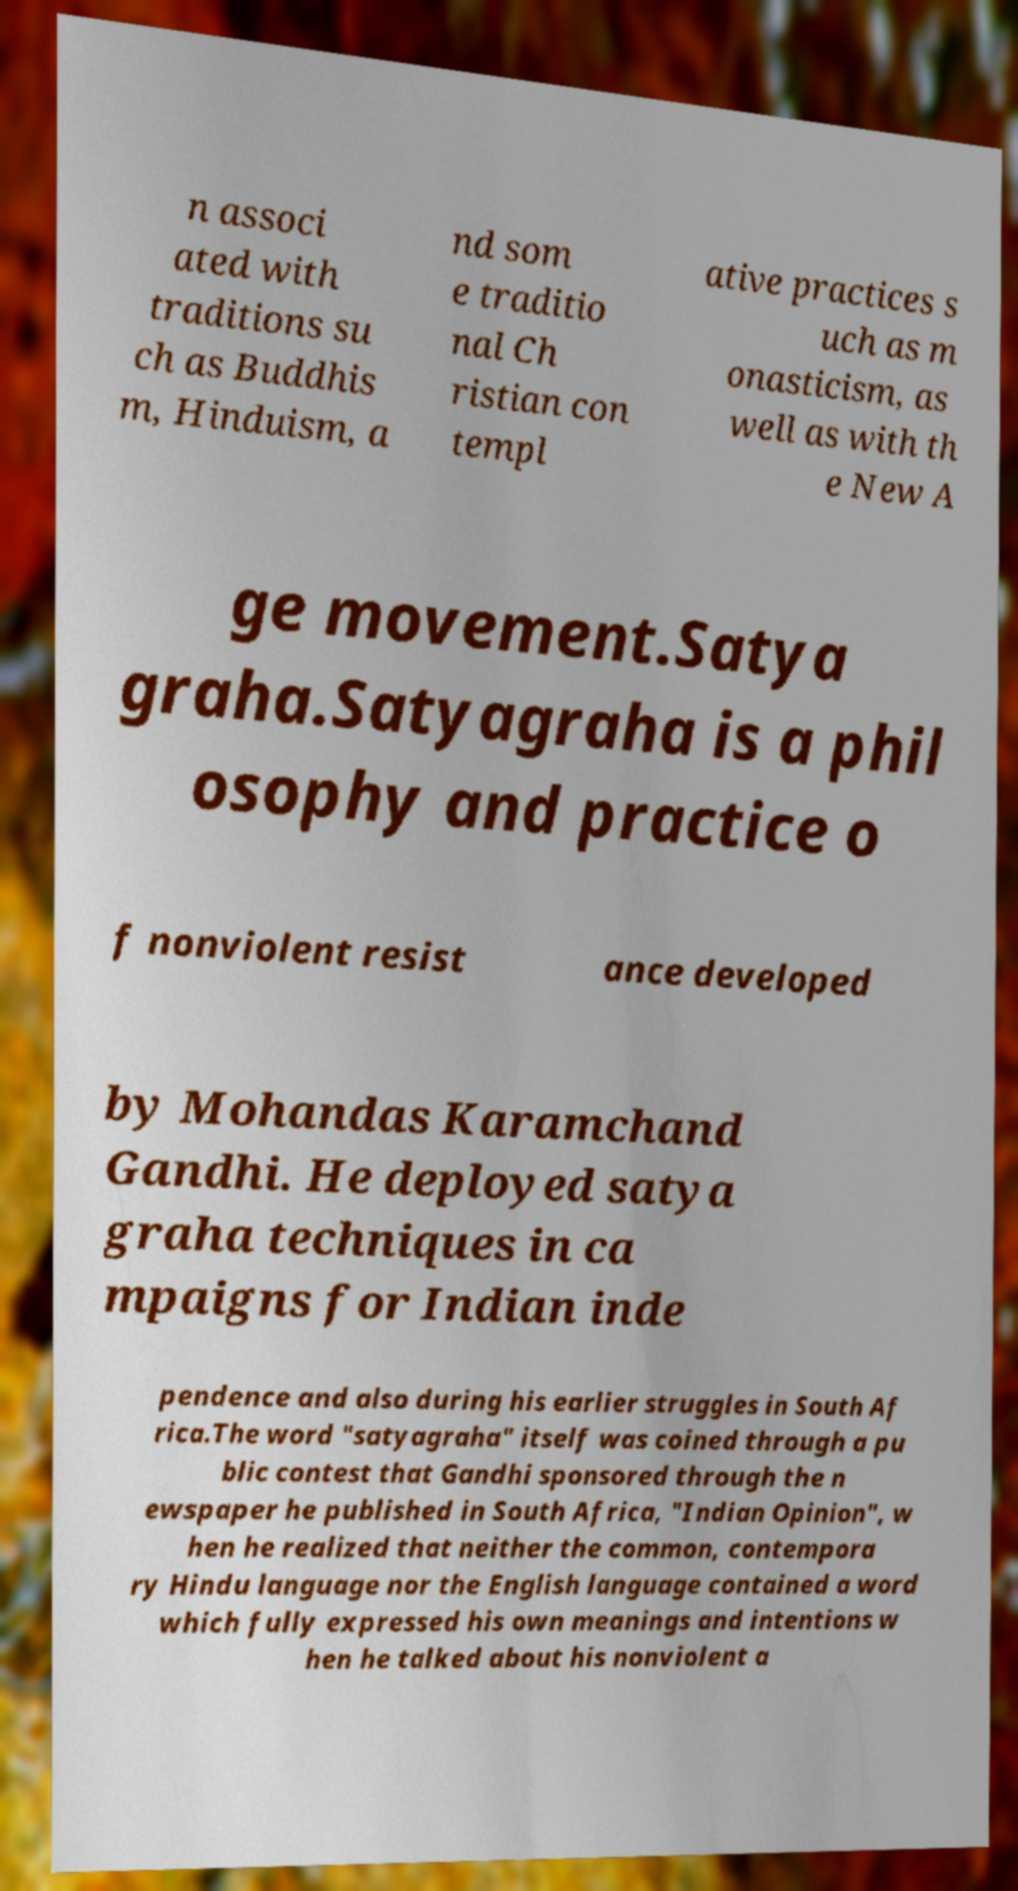There's text embedded in this image that I need extracted. Can you transcribe it verbatim? n associ ated with traditions su ch as Buddhis m, Hinduism, a nd som e traditio nal Ch ristian con templ ative practices s uch as m onasticism, as well as with th e New A ge movement.Satya graha.Satyagraha is a phil osophy and practice o f nonviolent resist ance developed by Mohandas Karamchand Gandhi. He deployed satya graha techniques in ca mpaigns for Indian inde pendence and also during his earlier struggles in South Af rica.The word "satyagraha" itself was coined through a pu blic contest that Gandhi sponsored through the n ewspaper he published in South Africa, "Indian Opinion", w hen he realized that neither the common, contempora ry Hindu language nor the English language contained a word which fully expressed his own meanings and intentions w hen he talked about his nonviolent a 